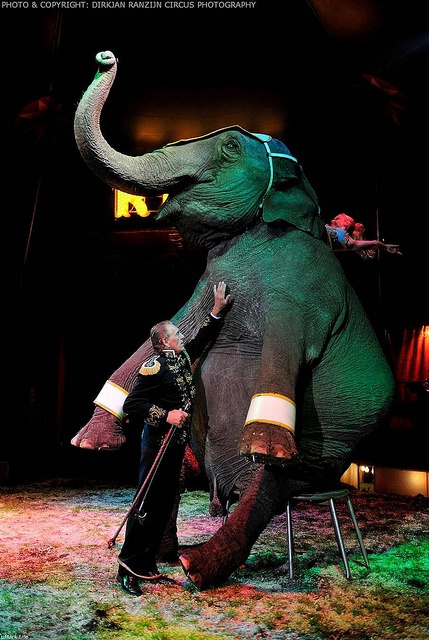Describe the objects in this image and their specific colors. I can see elephant in black, gray, teal, and darkgreen tones, people in black, gray, brown, and darkgray tones, people in black, maroon, salmon, and gray tones, and chair in black, gray, darkgray, and lightgray tones in this image. 